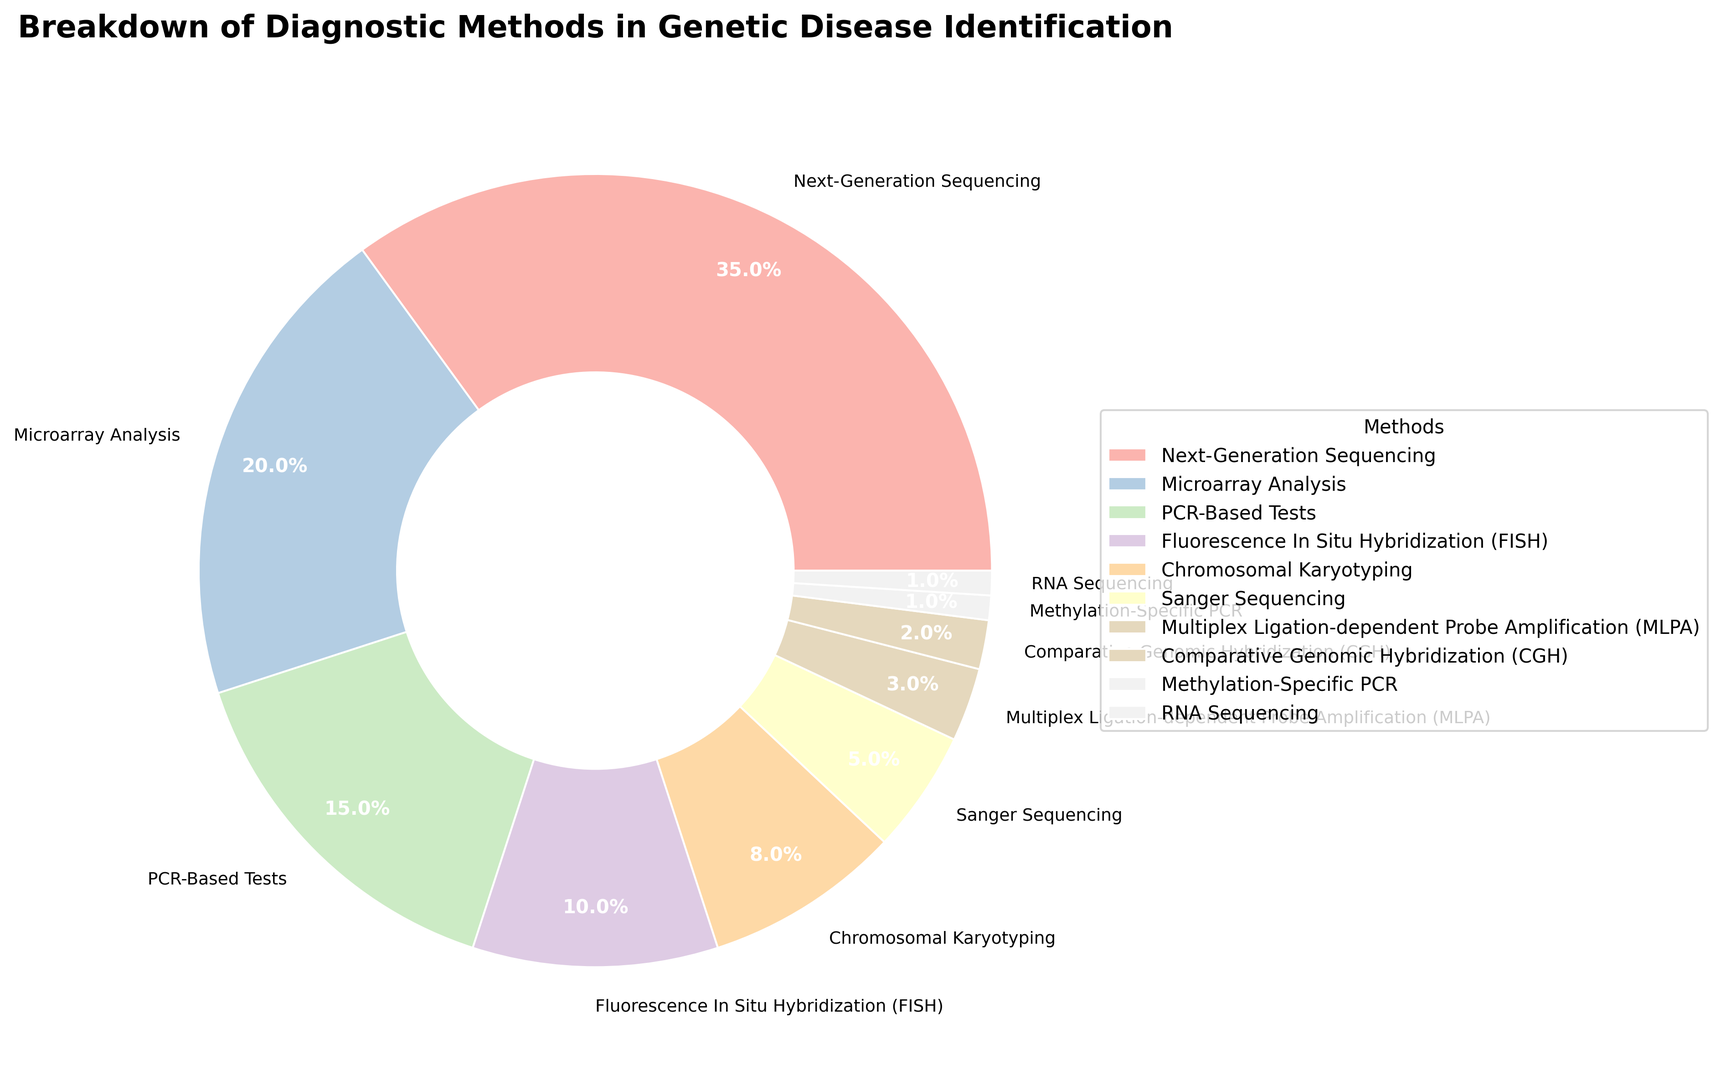Which method is used the most for genetic disease identification? Look for the largest section of the pie chart, which represents the method with the highest percentage.
Answer: Next-Generation Sequencing What is the combined percentage of Microarray Analysis and PCR-Based Tests? Locate the sections for Microarray Analysis and PCR-Based Tests and add their percentages together: 20% + 15% = 35%.
Answer: 35% How does the usage of PCR-Based Tests compare to Chromosomal Karyotyping? Check the percentages of both methods: PCR-Based Tests (15%) is greater than Chromosomal Karyotyping (8%).
Answer: PCR-Based Tests are used more Which methods are utilized less than 5% of the time? Identify sections with percentages less than 5%: Sanger Sequencing (5%), MLPA (3%), CGH (2%), and Methylation-Specific PCR (1%), RNA Sequencing (1%).
Answer: MLPA, CGH, Methylation-Specific PCR, RNA Sequencing What is the total percentage of the methods that use hybridization techniques? Add the percentages of hybridization techniques: FISH (10%), CGH (2%) = 12%.
Answer: 12% Is the combined usage of Sanger Sequencing and Chromosomal Karyotyping more than Next-Generation Sequencing? Sanger Sequencing (5%) + Chromosomal Karyotyping (8%) = 13%, which is less than Next-Generation Sequencing (35%).
Answer: No What percentage of diagnostic methods other than Next-Generation Sequencing and Microarray Analysis are used? Subtract the combined percentage of the two methods from 100%: 100% - (35%+20%) = 100% - 55% = 45%.
Answer: 45% Which method between FISH and PCR-Based Tests has a smaller percentage? Compare the percentages: FISH (10%) is less than PCR-Based Tests (15%).
Answer: FISH If methods above 5% are summed up, what is the resulting percentage? Sum all methods with percentages greater than 5%, i.e., Next-Generation Sequencing (35%), Microarray Analysis (20%), PCR-Based Tests (15%), FISH (10%), Chromosomal Karyotyping (8%): 35+20+15+10+8 = 88%.
Answer: 88% What percentage of methods are used less frequently than Chromosomal Karyotyping? Look for sections with percentages less than Chromosomal Karyotyping (8%): Sanger Sequencing (5%), MLPA (3%), CGH (2%), Methylation-Specific PCR (1%), RNA Sequencing (1%). Sum these percentages: 5+3+2+1+1 = 12%.
Answer: 12% 